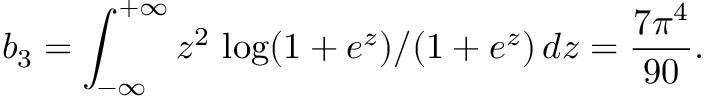Convert formula to latex. <formula><loc_0><loc_0><loc_500><loc_500>b _ { 3 } = \int _ { - \infty } ^ { + \infty } z ^ { 2 } \, \log ( 1 + e ^ { z } ) / ( 1 + e ^ { z } ) \, d z = \frac { 7 \pi ^ { 4 } } { 9 0 } .</formula> 